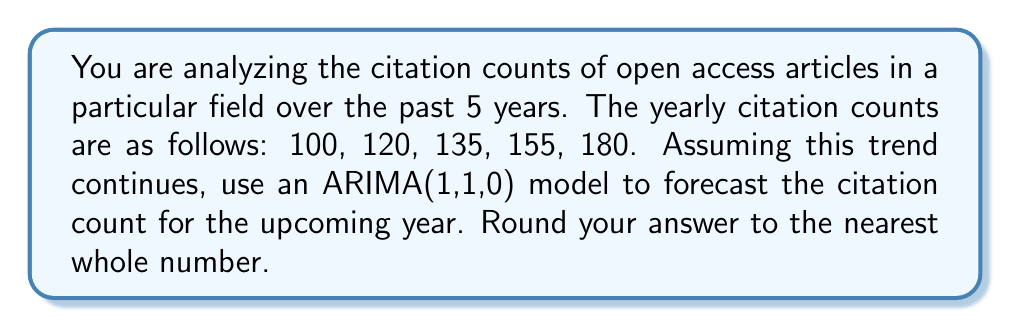Give your solution to this math problem. To solve this problem using an ARIMA(1,1,0) model, we'll follow these steps:

1) First, we need to difference the series once to make it stationary. Let's call the original series $y_t$ and the differenced series $w_t$:

   $w_t = y_t - y_{t-1}$

   Calculating the differences:
   $w_2 = 120 - 100 = 20$
   $w_3 = 135 - 120 = 15$
   $w_4 = 155 - 135 = 20$
   $w_5 = 180 - 155 = 25$

2) Now, we have a differenced series: 20, 15, 20, 25

3) For an ARIMA(1,1,0) model, we use the following equation:

   $w_t = c + \phi w_{t-1} + \epsilon_t$

   where $c$ is a constant, $\phi$ is the autoregressive parameter, and $\epsilon_t$ is white noise.

4) To estimate $\phi$, we can use the sample autocorrelation at lag 1:

   $\phi \approx r_1 = \frac{\sum_{t=2}^{n-1} (w_t - \bar{w})(w_{t+1} - \bar{w})}{\sum_{t=1}^{n} (w_t - \bar{w})^2}$

   Where $\bar{w}$ is the mean of the differenced series.

5) Calculating $\bar{w}$:
   $\bar{w} = (20 + 15 + 20 + 25) / 4 = 20$

6) Calculating $\phi$:
   $\phi \approx \frac{(20-20)(15-20) + (15-20)(20-20) + (20-20)(25-20)}{(20-20)^2 + (15-20)^2 + (20-20)^2 + (25-20)^2} \approx 0.1667$

7) Now we can forecast $w_6$:
   $w_6 = c + \phi w_5$
   
   We can estimate $c$ as $\bar{w}(1-\phi) = 20(1-0.1667) = 16.67$

   So, $w_6 = 16.67 + 0.1667(25) = 20.83$

8) To get the forecast for $y_6$, we need to "undifference" our result:
   $y_6 = y_5 + w_6 = 180 + 20.83 = 200.83$

9) Rounding to the nearest whole number: 201
Answer: 201 citations 